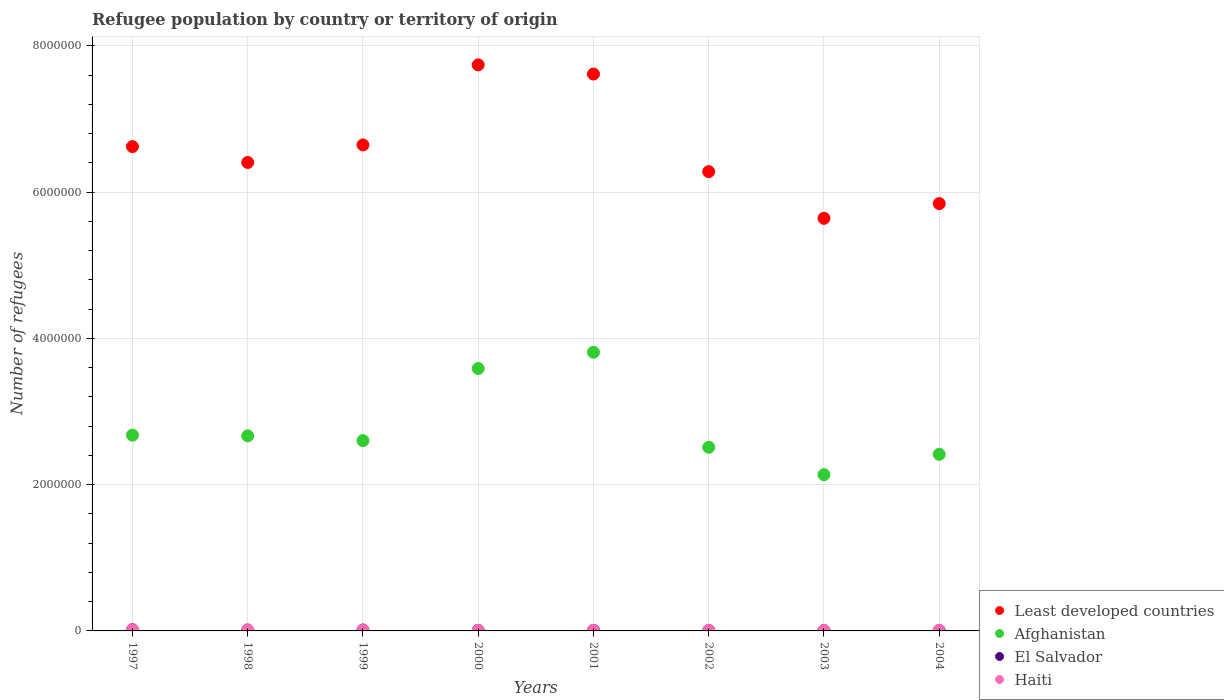Is the number of dotlines equal to the number of legend labels?
Provide a succinct answer. Yes. What is the number of refugees in El Salvador in 2004?
Your answer should be compact. 4497. Across all years, what is the maximum number of refugees in El Salvador?
Make the answer very short. 1.71e+04. Across all years, what is the minimum number of refugees in Haiti?
Make the answer very short. 7248. In which year was the number of refugees in Least developed countries maximum?
Ensure brevity in your answer.  2000. What is the total number of refugees in Haiti in the graph?
Provide a succinct answer. 7.71e+04. What is the difference between the number of refugees in Haiti in 1998 and that in 2001?
Make the answer very short. 6290. What is the difference between the number of refugees in El Salvador in 2003 and the number of refugees in Haiti in 2000?
Make the answer very short. -1903. What is the average number of refugees in El Salvador per year?
Provide a succinct answer. 9227.5. In the year 2003, what is the difference between the number of refugees in Afghanistan and number of refugees in El Salvador?
Give a very brief answer. 2.13e+06. In how many years, is the number of refugees in Haiti greater than 3200000?
Your answer should be very brief. 0. What is the ratio of the number of refugees in Afghanistan in 1997 to that in 2001?
Give a very brief answer. 0.7. Is the number of refugees in El Salvador in 1997 less than that in 1999?
Keep it short and to the point. No. Is the difference between the number of refugees in Afghanistan in 1997 and 2003 greater than the difference between the number of refugees in El Salvador in 1997 and 2003?
Make the answer very short. Yes. What is the difference between the highest and the second highest number of refugees in El Salvador?
Offer a terse response. 4535. What is the difference between the highest and the lowest number of refugees in Least developed countries?
Offer a terse response. 2.10e+06. Is the sum of the number of refugees in Afghanistan in 1999 and 2004 greater than the maximum number of refugees in Haiti across all years?
Keep it short and to the point. Yes. Is the number of refugees in El Salvador strictly greater than the number of refugees in Least developed countries over the years?
Make the answer very short. No. Are the values on the major ticks of Y-axis written in scientific E-notation?
Give a very brief answer. No. Does the graph contain grids?
Your response must be concise. Yes. Where does the legend appear in the graph?
Make the answer very short. Bottom right. How many legend labels are there?
Provide a succinct answer. 4. What is the title of the graph?
Make the answer very short. Refugee population by country or territory of origin. What is the label or title of the Y-axis?
Your answer should be very brief. Number of refugees. What is the Number of refugees in Least developed countries in 1997?
Your answer should be very brief. 6.62e+06. What is the Number of refugees of Afghanistan in 1997?
Make the answer very short. 2.68e+06. What is the Number of refugees of El Salvador in 1997?
Your answer should be very brief. 1.71e+04. What is the Number of refugees in Haiti in 1997?
Offer a terse response. 1.55e+04. What is the Number of refugees in Least developed countries in 1998?
Make the answer very short. 6.40e+06. What is the Number of refugees of Afghanistan in 1998?
Provide a succinct answer. 2.67e+06. What is the Number of refugees in El Salvador in 1998?
Keep it short and to the point. 1.26e+04. What is the Number of refugees in Haiti in 1998?
Make the answer very short. 1.35e+04. What is the Number of refugees of Least developed countries in 1999?
Your answer should be very brief. 6.64e+06. What is the Number of refugees in Afghanistan in 1999?
Keep it short and to the point. 2.60e+06. What is the Number of refugees in El Salvador in 1999?
Your answer should be compact. 1.24e+04. What is the Number of refugees of Haiti in 1999?
Give a very brief answer. 8766. What is the Number of refugees of Least developed countries in 2000?
Make the answer very short. 7.74e+06. What is the Number of refugees of Afghanistan in 2000?
Your response must be concise. 3.59e+06. What is the Number of refugees of El Salvador in 2000?
Offer a terse response. 7756. What is the Number of refugees of Haiti in 2000?
Your response must be concise. 7561. What is the Number of refugees of Least developed countries in 2001?
Ensure brevity in your answer.  7.61e+06. What is the Number of refugees of Afghanistan in 2001?
Your answer should be compact. 3.81e+06. What is the Number of refugees in El Salvador in 2001?
Offer a terse response. 7150. What is the Number of refugees in Haiti in 2001?
Offer a very short reply. 7248. What is the Number of refugees of Least developed countries in 2002?
Give a very brief answer. 6.28e+06. What is the Number of refugees of Afghanistan in 2002?
Provide a short and direct response. 2.51e+06. What is the Number of refugees of El Salvador in 2002?
Provide a short and direct response. 6632. What is the Number of refugees in Haiti in 2002?
Ensure brevity in your answer.  7718. What is the Number of refugees of Least developed countries in 2003?
Provide a short and direct response. 5.64e+06. What is the Number of refugees of Afghanistan in 2003?
Your response must be concise. 2.14e+06. What is the Number of refugees in El Salvador in 2003?
Give a very brief answer. 5658. What is the Number of refugees in Haiti in 2003?
Make the answer very short. 7547. What is the Number of refugees of Least developed countries in 2004?
Keep it short and to the point. 5.84e+06. What is the Number of refugees of Afghanistan in 2004?
Offer a very short reply. 2.41e+06. What is the Number of refugees in El Salvador in 2004?
Offer a very short reply. 4497. What is the Number of refugees in Haiti in 2004?
Make the answer very short. 9208. Across all years, what is the maximum Number of refugees of Least developed countries?
Offer a very short reply. 7.74e+06. Across all years, what is the maximum Number of refugees in Afghanistan?
Keep it short and to the point. 3.81e+06. Across all years, what is the maximum Number of refugees of El Salvador?
Give a very brief answer. 1.71e+04. Across all years, what is the maximum Number of refugees in Haiti?
Provide a short and direct response. 1.55e+04. Across all years, what is the minimum Number of refugees of Least developed countries?
Your answer should be compact. 5.64e+06. Across all years, what is the minimum Number of refugees in Afghanistan?
Give a very brief answer. 2.14e+06. Across all years, what is the minimum Number of refugees of El Salvador?
Ensure brevity in your answer.  4497. Across all years, what is the minimum Number of refugees of Haiti?
Ensure brevity in your answer.  7248. What is the total Number of refugees in Least developed countries in the graph?
Ensure brevity in your answer.  5.28e+07. What is the total Number of refugees in Afghanistan in the graph?
Offer a very short reply. 2.24e+07. What is the total Number of refugees of El Salvador in the graph?
Your answer should be compact. 7.38e+04. What is the total Number of refugees of Haiti in the graph?
Offer a very short reply. 7.71e+04. What is the difference between the Number of refugees in Least developed countries in 1997 and that in 1998?
Your answer should be very brief. 2.17e+05. What is the difference between the Number of refugees in Afghanistan in 1997 and that in 1998?
Keep it short and to the point. 9559. What is the difference between the Number of refugees in El Salvador in 1997 and that in 1998?
Offer a terse response. 4535. What is the difference between the Number of refugees of Haiti in 1997 and that in 1998?
Provide a short and direct response. 1943. What is the difference between the Number of refugees of Least developed countries in 1997 and that in 1999?
Ensure brevity in your answer.  -2.28e+04. What is the difference between the Number of refugees of Afghanistan in 1997 and that in 1999?
Your response must be concise. 7.50e+04. What is the difference between the Number of refugees of El Salvador in 1997 and that in 1999?
Keep it short and to the point. 4716. What is the difference between the Number of refugees of Haiti in 1997 and that in 1999?
Offer a very short reply. 6715. What is the difference between the Number of refugees in Least developed countries in 1997 and that in 2000?
Give a very brief answer. -1.12e+06. What is the difference between the Number of refugees of Afghanistan in 1997 and that in 2000?
Your answer should be very brief. -9.11e+05. What is the difference between the Number of refugees in El Salvador in 1997 and that in 2000?
Make the answer very short. 9370. What is the difference between the Number of refugees of Haiti in 1997 and that in 2000?
Make the answer very short. 7920. What is the difference between the Number of refugees of Least developed countries in 1997 and that in 2001?
Offer a very short reply. -9.92e+05. What is the difference between the Number of refugees in Afghanistan in 1997 and that in 2001?
Your answer should be compact. -1.13e+06. What is the difference between the Number of refugees of El Salvador in 1997 and that in 2001?
Keep it short and to the point. 9976. What is the difference between the Number of refugees in Haiti in 1997 and that in 2001?
Make the answer very short. 8233. What is the difference between the Number of refugees in Least developed countries in 1997 and that in 2002?
Offer a very short reply. 3.42e+05. What is the difference between the Number of refugees of Afghanistan in 1997 and that in 2002?
Offer a very short reply. 1.66e+05. What is the difference between the Number of refugees of El Salvador in 1997 and that in 2002?
Offer a terse response. 1.05e+04. What is the difference between the Number of refugees of Haiti in 1997 and that in 2002?
Give a very brief answer. 7763. What is the difference between the Number of refugees of Least developed countries in 1997 and that in 2003?
Your answer should be compact. 9.80e+05. What is the difference between the Number of refugees of Afghanistan in 1997 and that in 2003?
Your answer should be very brief. 5.41e+05. What is the difference between the Number of refugees in El Salvador in 1997 and that in 2003?
Offer a terse response. 1.15e+04. What is the difference between the Number of refugees in Haiti in 1997 and that in 2003?
Make the answer very short. 7934. What is the difference between the Number of refugees of Least developed countries in 1997 and that in 2004?
Give a very brief answer. 7.79e+05. What is the difference between the Number of refugees in Afghanistan in 1997 and that in 2004?
Your answer should be compact. 2.62e+05. What is the difference between the Number of refugees in El Salvador in 1997 and that in 2004?
Ensure brevity in your answer.  1.26e+04. What is the difference between the Number of refugees in Haiti in 1997 and that in 2004?
Offer a very short reply. 6273. What is the difference between the Number of refugees in Least developed countries in 1998 and that in 1999?
Provide a succinct answer. -2.40e+05. What is the difference between the Number of refugees in Afghanistan in 1998 and that in 1999?
Keep it short and to the point. 6.54e+04. What is the difference between the Number of refugees in El Salvador in 1998 and that in 1999?
Provide a short and direct response. 181. What is the difference between the Number of refugees of Haiti in 1998 and that in 1999?
Offer a very short reply. 4772. What is the difference between the Number of refugees of Least developed countries in 1998 and that in 2000?
Give a very brief answer. -1.33e+06. What is the difference between the Number of refugees in Afghanistan in 1998 and that in 2000?
Your answer should be very brief. -9.20e+05. What is the difference between the Number of refugees in El Salvador in 1998 and that in 2000?
Keep it short and to the point. 4835. What is the difference between the Number of refugees of Haiti in 1998 and that in 2000?
Offer a very short reply. 5977. What is the difference between the Number of refugees in Least developed countries in 1998 and that in 2001?
Provide a succinct answer. -1.21e+06. What is the difference between the Number of refugees in Afghanistan in 1998 and that in 2001?
Your answer should be compact. -1.14e+06. What is the difference between the Number of refugees of El Salvador in 1998 and that in 2001?
Give a very brief answer. 5441. What is the difference between the Number of refugees of Haiti in 1998 and that in 2001?
Provide a short and direct response. 6290. What is the difference between the Number of refugees of Least developed countries in 1998 and that in 2002?
Make the answer very short. 1.25e+05. What is the difference between the Number of refugees of Afghanistan in 1998 and that in 2002?
Give a very brief answer. 1.57e+05. What is the difference between the Number of refugees in El Salvador in 1998 and that in 2002?
Your response must be concise. 5959. What is the difference between the Number of refugees of Haiti in 1998 and that in 2002?
Offer a very short reply. 5820. What is the difference between the Number of refugees of Least developed countries in 1998 and that in 2003?
Keep it short and to the point. 7.63e+05. What is the difference between the Number of refugees in Afghanistan in 1998 and that in 2003?
Ensure brevity in your answer.  5.31e+05. What is the difference between the Number of refugees in El Salvador in 1998 and that in 2003?
Your response must be concise. 6933. What is the difference between the Number of refugees in Haiti in 1998 and that in 2003?
Your answer should be compact. 5991. What is the difference between the Number of refugees in Least developed countries in 1998 and that in 2004?
Offer a very short reply. 5.62e+05. What is the difference between the Number of refugees of Afghanistan in 1998 and that in 2004?
Your answer should be compact. 2.53e+05. What is the difference between the Number of refugees of El Salvador in 1998 and that in 2004?
Give a very brief answer. 8094. What is the difference between the Number of refugees in Haiti in 1998 and that in 2004?
Your answer should be compact. 4330. What is the difference between the Number of refugees in Least developed countries in 1999 and that in 2000?
Your answer should be very brief. -1.09e+06. What is the difference between the Number of refugees of Afghanistan in 1999 and that in 2000?
Keep it short and to the point. -9.86e+05. What is the difference between the Number of refugees in El Salvador in 1999 and that in 2000?
Keep it short and to the point. 4654. What is the difference between the Number of refugees of Haiti in 1999 and that in 2000?
Your answer should be very brief. 1205. What is the difference between the Number of refugees of Least developed countries in 1999 and that in 2001?
Ensure brevity in your answer.  -9.69e+05. What is the difference between the Number of refugees in Afghanistan in 1999 and that in 2001?
Offer a terse response. -1.21e+06. What is the difference between the Number of refugees in El Salvador in 1999 and that in 2001?
Offer a very short reply. 5260. What is the difference between the Number of refugees of Haiti in 1999 and that in 2001?
Give a very brief answer. 1518. What is the difference between the Number of refugees in Least developed countries in 1999 and that in 2002?
Provide a succinct answer. 3.64e+05. What is the difference between the Number of refugees of Afghanistan in 1999 and that in 2002?
Your answer should be compact. 9.14e+04. What is the difference between the Number of refugees of El Salvador in 1999 and that in 2002?
Your answer should be compact. 5778. What is the difference between the Number of refugees of Haiti in 1999 and that in 2002?
Provide a succinct answer. 1048. What is the difference between the Number of refugees of Least developed countries in 1999 and that in 2003?
Your answer should be compact. 1.00e+06. What is the difference between the Number of refugees of Afghanistan in 1999 and that in 2003?
Offer a very short reply. 4.66e+05. What is the difference between the Number of refugees in El Salvador in 1999 and that in 2003?
Offer a terse response. 6752. What is the difference between the Number of refugees in Haiti in 1999 and that in 2003?
Offer a very short reply. 1219. What is the difference between the Number of refugees in Least developed countries in 1999 and that in 2004?
Your answer should be compact. 8.02e+05. What is the difference between the Number of refugees in Afghanistan in 1999 and that in 2004?
Your response must be concise. 1.87e+05. What is the difference between the Number of refugees of El Salvador in 1999 and that in 2004?
Provide a short and direct response. 7913. What is the difference between the Number of refugees in Haiti in 1999 and that in 2004?
Your response must be concise. -442. What is the difference between the Number of refugees of Least developed countries in 2000 and that in 2001?
Provide a short and direct response. 1.26e+05. What is the difference between the Number of refugees in Afghanistan in 2000 and that in 2001?
Give a very brief answer. -2.22e+05. What is the difference between the Number of refugees of El Salvador in 2000 and that in 2001?
Make the answer very short. 606. What is the difference between the Number of refugees in Haiti in 2000 and that in 2001?
Provide a short and direct response. 313. What is the difference between the Number of refugees of Least developed countries in 2000 and that in 2002?
Give a very brief answer. 1.46e+06. What is the difference between the Number of refugees of Afghanistan in 2000 and that in 2002?
Your answer should be compact. 1.08e+06. What is the difference between the Number of refugees in El Salvador in 2000 and that in 2002?
Offer a very short reply. 1124. What is the difference between the Number of refugees of Haiti in 2000 and that in 2002?
Give a very brief answer. -157. What is the difference between the Number of refugees of Least developed countries in 2000 and that in 2003?
Keep it short and to the point. 2.10e+06. What is the difference between the Number of refugees in Afghanistan in 2000 and that in 2003?
Your response must be concise. 1.45e+06. What is the difference between the Number of refugees in El Salvador in 2000 and that in 2003?
Keep it short and to the point. 2098. What is the difference between the Number of refugees of Least developed countries in 2000 and that in 2004?
Make the answer very short. 1.90e+06. What is the difference between the Number of refugees in Afghanistan in 2000 and that in 2004?
Ensure brevity in your answer.  1.17e+06. What is the difference between the Number of refugees in El Salvador in 2000 and that in 2004?
Ensure brevity in your answer.  3259. What is the difference between the Number of refugees of Haiti in 2000 and that in 2004?
Provide a short and direct response. -1647. What is the difference between the Number of refugees in Least developed countries in 2001 and that in 2002?
Give a very brief answer. 1.33e+06. What is the difference between the Number of refugees of Afghanistan in 2001 and that in 2002?
Your answer should be very brief. 1.30e+06. What is the difference between the Number of refugees of El Salvador in 2001 and that in 2002?
Make the answer very short. 518. What is the difference between the Number of refugees of Haiti in 2001 and that in 2002?
Your response must be concise. -470. What is the difference between the Number of refugees of Least developed countries in 2001 and that in 2003?
Give a very brief answer. 1.97e+06. What is the difference between the Number of refugees in Afghanistan in 2001 and that in 2003?
Provide a short and direct response. 1.67e+06. What is the difference between the Number of refugees in El Salvador in 2001 and that in 2003?
Ensure brevity in your answer.  1492. What is the difference between the Number of refugees of Haiti in 2001 and that in 2003?
Keep it short and to the point. -299. What is the difference between the Number of refugees in Least developed countries in 2001 and that in 2004?
Provide a short and direct response. 1.77e+06. What is the difference between the Number of refugees of Afghanistan in 2001 and that in 2004?
Ensure brevity in your answer.  1.40e+06. What is the difference between the Number of refugees in El Salvador in 2001 and that in 2004?
Provide a succinct answer. 2653. What is the difference between the Number of refugees in Haiti in 2001 and that in 2004?
Provide a short and direct response. -1960. What is the difference between the Number of refugees in Least developed countries in 2002 and that in 2003?
Ensure brevity in your answer.  6.39e+05. What is the difference between the Number of refugees of Afghanistan in 2002 and that in 2003?
Offer a terse response. 3.74e+05. What is the difference between the Number of refugees in El Salvador in 2002 and that in 2003?
Your answer should be compact. 974. What is the difference between the Number of refugees in Haiti in 2002 and that in 2003?
Offer a terse response. 171. What is the difference between the Number of refugees of Least developed countries in 2002 and that in 2004?
Provide a short and direct response. 4.38e+05. What is the difference between the Number of refugees in Afghanistan in 2002 and that in 2004?
Make the answer very short. 9.59e+04. What is the difference between the Number of refugees in El Salvador in 2002 and that in 2004?
Your response must be concise. 2135. What is the difference between the Number of refugees in Haiti in 2002 and that in 2004?
Provide a succinct answer. -1490. What is the difference between the Number of refugees of Least developed countries in 2003 and that in 2004?
Ensure brevity in your answer.  -2.01e+05. What is the difference between the Number of refugees of Afghanistan in 2003 and that in 2004?
Your answer should be very brief. -2.78e+05. What is the difference between the Number of refugees of El Salvador in 2003 and that in 2004?
Your answer should be compact. 1161. What is the difference between the Number of refugees of Haiti in 2003 and that in 2004?
Your answer should be very brief. -1661. What is the difference between the Number of refugees of Least developed countries in 1997 and the Number of refugees of Afghanistan in 1998?
Your answer should be very brief. 3.95e+06. What is the difference between the Number of refugees of Least developed countries in 1997 and the Number of refugees of El Salvador in 1998?
Provide a succinct answer. 6.61e+06. What is the difference between the Number of refugees in Least developed countries in 1997 and the Number of refugees in Haiti in 1998?
Keep it short and to the point. 6.61e+06. What is the difference between the Number of refugees in Afghanistan in 1997 and the Number of refugees in El Salvador in 1998?
Your response must be concise. 2.66e+06. What is the difference between the Number of refugees in Afghanistan in 1997 and the Number of refugees in Haiti in 1998?
Ensure brevity in your answer.  2.66e+06. What is the difference between the Number of refugees of El Salvador in 1997 and the Number of refugees of Haiti in 1998?
Offer a terse response. 3588. What is the difference between the Number of refugees of Least developed countries in 1997 and the Number of refugees of Afghanistan in 1999?
Offer a very short reply. 4.02e+06. What is the difference between the Number of refugees in Least developed countries in 1997 and the Number of refugees in El Salvador in 1999?
Offer a very short reply. 6.61e+06. What is the difference between the Number of refugees in Least developed countries in 1997 and the Number of refugees in Haiti in 1999?
Ensure brevity in your answer.  6.61e+06. What is the difference between the Number of refugees in Afghanistan in 1997 and the Number of refugees in El Salvador in 1999?
Your answer should be compact. 2.66e+06. What is the difference between the Number of refugees of Afghanistan in 1997 and the Number of refugees of Haiti in 1999?
Offer a very short reply. 2.67e+06. What is the difference between the Number of refugees of El Salvador in 1997 and the Number of refugees of Haiti in 1999?
Your response must be concise. 8360. What is the difference between the Number of refugees of Least developed countries in 1997 and the Number of refugees of Afghanistan in 2000?
Your answer should be very brief. 3.03e+06. What is the difference between the Number of refugees in Least developed countries in 1997 and the Number of refugees in El Salvador in 2000?
Provide a succinct answer. 6.61e+06. What is the difference between the Number of refugees of Least developed countries in 1997 and the Number of refugees of Haiti in 2000?
Offer a terse response. 6.61e+06. What is the difference between the Number of refugees in Afghanistan in 1997 and the Number of refugees in El Salvador in 2000?
Give a very brief answer. 2.67e+06. What is the difference between the Number of refugees in Afghanistan in 1997 and the Number of refugees in Haiti in 2000?
Make the answer very short. 2.67e+06. What is the difference between the Number of refugees of El Salvador in 1997 and the Number of refugees of Haiti in 2000?
Give a very brief answer. 9565. What is the difference between the Number of refugees of Least developed countries in 1997 and the Number of refugees of Afghanistan in 2001?
Offer a terse response. 2.81e+06. What is the difference between the Number of refugees of Least developed countries in 1997 and the Number of refugees of El Salvador in 2001?
Your response must be concise. 6.61e+06. What is the difference between the Number of refugees of Least developed countries in 1997 and the Number of refugees of Haiti in 2001?
Provide a succinct answer. 6.61e+06. What is the difference between the Number of refugees of Afghanistan in 1997 and the Number of refugees of El Salvador in 2001?
Your answer should be compact. 2.67e+06. What is the difference between the Number of refugees in Afghanistan in 1997 and the Number of refugees in Haiti in 2001?
Make the answer very short. 2.67e+06. What is the difference between the Number of refugees of El Salvador in 1997 and the Number of refugees of Haiti in 2001?
Your answer should be compact. 9878. What is the difference between the Number of refugees in Least developed countries in 1997 and the Number of refugees in Afghanistan in 2002?
Make the answer very short. 4.11e+06. What is the difference between the Number of refugees in Least developed countries in 1997 and the Number of refugees in El Salvador in 2002?
Ensure brevity in your answer.  6.61e+06. What is the difference between the Number of refugees in Least developed countries in 1997 and the Number of refugees in Haiti in 2002?
Keep it short and to the point. 6.61e+06. What is the difference between the Number of refugees in Afghanistan in 1997 and the Number of refugees in El Salvador in 2002?
Offer a very short reply. 2.67e+06. What is the difference between the Number of refugees of Afghanistan in 1997 and the Number of refugees of Haiti in 2002?
Offer a very short reply. 2.67e+06. What is the difference between the Number of refugees in El Salvador in 1997 and the Number of refugees in Haiti in 2002?
Give a very brief answer. 9408. What is the difference between the Number of refugees in Least developed countries in 1997 and the Number of refugees in Afghanistan in 2003?
Offer a terse response. 4.49e+06. What is the difference between the Number of refugees of Least developed countries in 1997 and the Number of refugees of El Salvador in 2003?
Provide a short and direct response. 6.62e+06. What is the difference between the Number of refugees in Least developed countries in 1997 and the Number of refugees in Haiti in 2003?
Give a very brief answer. 6.61e+06. What is the difference between the Number of refugees of Afghanistan in 1997 and the Number of refugees of El Salvador in 2003?
Your answer should be compact. 2.67e+06. What is the difference between the Number of refugees in Afghanistan in 1997 and the Number of refugees in Haiti in 2003?
Provide a succinct answer. 2.67e+06. What is the difference between the Number of refugees in El Salvador in 1997 and the Number of refugees in Haiti in 2003?
Ensure brevity in your answer.  9579. What is the difference between the Number of refugees of Least developed countries in 1997 and the Number of refugees of Afghanistan in 2004?
Your answer should be compact. 4.21e+06. What is the difference between the Number of refugees of Least developed countries in 1997 and the Number of refugees of El Salvador in 2004?
Give a very brief answer. 6.62e+06. What is the difference between the Number of refugees in Least developed countries in 1997 and the Number of refugees in Haiti in 2004?
Provide a short and direct response. 6.61e+06. What is the difference between the Number of refugees of Afghanistan in 1997 and the Number of refugees of El Salvador in 2004?
Keep it short and to the point. 2.67e+06. What is the difference between the Number of refugees of Afghanistan in 1997 and the Number of refugees of Haiti in 2004?
Offer a very short reply. 2.67e+06. What is the difference between the Number of refugees of El Salvador in 1997 and the Number of refugees of Haiti in 2004?
Provide a succinct answer. 7918. What is the difference between the Number of refugees of Least developed countries in 1998 and the Number of refugees of Afghanistan in 1999?
Your answer should be very brief. 3.80e+06. What is the difference between the Number of refugees of Least developed countries in 1998 and the Number of refugees of El Salvador in 1999?
Provide a short and direct response. 6.39e+06. What is the difference between the Number of refugees of Least developed countries in 1998 and the Number of refugees of Haiti in 1999?
Your answer should be compact. 6.40e+06. What is the difference between the Number of refugees of Afghanistan in 1998 and the Number of refugees of El Salvador in 1999?
Provide a short and direct response. 2.65e+06. What is the difference between the Number of refugees in Afghanistan in 1998 and the Number of refugees in Haiti in 1999?
Offer a terse response. 2.66e+06. What is the difference between the Number of refugees in El Salvador in 1998 and the Number of refugees in Haiti in 1999?
Provide a succinct answer. 3825. What is the difference between the Number of refugees in Least developed countries in 1998 and the Number of refugees in Afghanistan in 2000?
Make the answer very short. 2.82e+06. What is the difference between the Number of refugees of Least developed countries in 1998 and the Number of refugees of El Salvador in 2000?
Your answer should be very brief. 6.40e+06. What is the difference between the Number of refugees of Least developed countries in 1998 and the Number of refugees of Haiti in 2000?
Your answer should be very brief. 6.40e+06. What is the difference between the Number of refugees of Afghanistan in 1998 and the Number of refugees of El Salvador in 2000?
Make the answer very short. 2.66e+06. What is the difference between the Number of refugees in Afghanistan in 1998 and the Number of refugees in Haiti in 2000?
Make the answer very short. 2.66e+06. What is the difference between the Number of refugees in El Salvador in 1998 and the Number of refugees in Haiti in 2000?
Provide a short and direct response. 5030. What is the difference between the Number of refugees in Least developed countries in 1998 and the Number of refugees in Afghanistan in 2001?
Offer a very short reply. 2.59e+06. What is the difference between the Number of refugees in Least developed countries in 1998 and the Number of refugees in El Salvador in 2001?
Make the answer very short. 6.40e+06. What is the difference between the Number of refugees of Least developed countries in 1998 and the Number of refugees of Haiti in 2001?
Keep it short and to the point. 6.40e+06. What is the difference between the Number of refugees in Afghanistan in 1998 and the Number of refugees in El Salvador in 2001?
Your answer should be compact. 2.66e+06. What is the difference between the Number of refugees in Afghanistan in 1998 and the Number of refugees in Haiti in 2001?
Your response must be concise. 2.66e+06. What is the difference between the Number of refugees of El Salvador in 1998 and the Number of refugees of Haiti in 2001?
Your answer should be very brief. 5343. What is the difference between the Number of refugees of Least developed countries in 1998 and the Number of refugees of Afghanistan in 2002?
Provide a short and direct response. 3.89e+06. What is the difference between the Number of refugees in Least developed countries in 1998 and the Number of refugees in El Salvador in 2002?
Your response must be concise. 6.40e+06. What is the difference between the Number of refugees of Least developed countries in 1998 and the Number of refugees of Haiti in 2002?
Provide a succinct answer. 6.40e+06. What is the difference between the Number of refugees of Afghanistan in 1998 and the Number of refugees of El Salvador in 2002?
Ensure brevity in your answer.  2.66e+06. What is the difference between the Number of refugees in Afghanistan in 1998 and the Number of refugees in Haiti in 2002?
Ensure brevity in your answer.  2.66e+06. What is the difference between the Number of refugees in El Salvador in 1998 and the Number of refugees in Haiti in 2002?
Offer a terse response. 4873. What is the difference between the Number of refugees of Least developed countries in 1998 and the Number of refugees of Afghanistan in 2003?
Offer a very short reply. 4.27e+06. What is the difference between the Number of refugees of Least developed countries in 1998 and the Number of refugees of El Salvador in 2003?
Your answer should be compact. 6.40e+06. What is the difference between the Number of refugees in Least developed countries in 1998 and the Number of refugees in Haiti in 2003?
Provide a short and direct response. 6.40e+06. What is the difference between the Number of refugees of Afghanistan in 1998 and the Number of refugees of El Salvador in 2003?
Your answer should be compact. 2.66e+06. What is the difference between the Number of refugees in Afghanistan in 1998 and the Number of refugees in Haiti in 2003?
Ensure brevity in your answer.  2.66e+06. What is the difference between the Number of refugees in El Salvador in 1998 and the Number of refugees in Haiti in 2003?
Your answer should be compact. 5044. What is the difference between the Number of refugees in Least developed countries in 1998 and the Number of refugees in Afghanistan in 2004?
Ensure brevity in your answer.  3.99e+06. What is the difference between the Number of refugees in Least developed countries in 1998 and the Number of refugees in El Salvador in 2004?
Give a very brief answer. 6.40e+06. What is the difference between the Number of refugees in Least developed countries in 1998 and the Number of refugees in Haiti in 2004?
Ensure brevity in your answer.  6.40e+06. What is the difference between the Number of refugees in Afghanistan in 1998 and the Number of refugees in El Salvador in 2004?
Make the answer very short. 2.66e+06. What is the difference between the Number of refugees of Afghanistan in 1998 and the Number of refugees of Haiti in 2004?
Your response must be concise. 2.66e+06. What is the difference between the Number of refugees in El Salvador in 1998 and the Number of refugees in Haiti in 2004?
Your answer should be very brief. 3383. What is the difference between the Number of refugees of Least developed countries in 1999 and the Number of refugees of Afghanistan in 2000?
Your response must be concise. 3.06e+06. What is the difference between the Number of refugees in Least developed countries in 1999 and the Number of refugees in El Salvador in 2000?
Make the answer very short. 6.64e+06. What is the difference between the Number of refugees of Least developed countries in 1999 and the Number of refugees of Haiti in 2000?
Offer a very short reply. 6.64e+06. What is the difference between the Number of refugees of Afghanistan in 1999 and the Number of refugees of El Salvador in 2000?
Give a very brief answer. 2.59e+06. What is the difference between the Number of refugees in Afghanistan in 1999 and the Number of refugees in Haiti in 2000?
Make the answer very short. 2.59e+06. What is the difference between the Number of refugees in El Salvador in 1999 and the Number of refugees in Haiti in 2000?
Your answer should be compact. 4849. What is the difference between the Number of refugees of Least developed countries in 1999 and the Number of refugees of Afghanistan in 2001?
Provide a succinct answer. 2.83e+06. What is the difference between the Number of refugees in Least developed countries in 1999 and the Number of refugees in El Salvador in 2001?
Your response must be concise. 6.64e+06. What is the difference between the Number of refugees in Least developed countries in 1999 and the Number of refugees in Haiti in 2001?
Make the answer very short. 6.64e+06. What is the difference between the Number of refugees in Afghanistan in 1999 and the Number of refugees in El Salvador in 2001?
Offer a very short reply. 2.59e+06. What is the difference between the Number of refugees in Afghanistan in 1999 and the Number of refugees in Haiti in 2001?
Provide a short and direct response. 2.59e+06. What is the difference between the Number of refugees in El Salvador in 1999 and the Number of refugees in Haiti in 2001?
Provide a short and direct response. 5162. What is the difference between the Number of refugees in Least developed countries in 1999 and the Number of refugees in Afghanistan in 2002?
Provide a short and direct response. 4.13e+06. What is the difference between the Number of refugees in Least developed countries in 1999 and the Number of refugees in El Salvador in 2002?
Offer a very short reply. 6.64e+06. What is the difference between the Number of refugees in Least developed countries in 1999 and the Number of refugees in Haiti in 2002?
Ensure brevity in your answer.  6.64e+06. What is the difference between the Number of refugees in Afghanistan in 1999 and the Number of refugees in El Salvador in 2002?
Keep it short and to the point. 2.60e+06. What is the difference between the Number of refugees of Afghanistan in 1999 and the Number of refugees of Haiti in 2002?
Ensure brevity in your answer.  2.59e+06. What is the difference between the Number of refugees in El Salvador in 1999 and the Number of refugees in Haiti in 2002?
Ensure brevity in your answer.  4692. What is the difference between the Number of refugees in Least developed countries in 1999 and the Number of refugees in Afghanistan in 2003?
Ensure brevity in your answer.  4.51e+06. What is the difference between the Number of refugees of Least developed countries in 1999 and the Number of refugees of El Salvador in 2003?
Offer a terse response. 6.64e+06. What is the difference between the Number of refugees in Least developed countries in 1999 and the Number of refugees in Haiti in 2003?
Keep it short and to the point. 6.64e+06. What is the difference between the Number of refugees of Afghanistan in 1999 and the Number of refugees of El Salvador in 2003?
Provide a succinct answer. 2.60e+06. What is the difference between the Number of refugees of Afghanistan in 1999 and the Number of refugees of Haiti in 2003?
Your answer should be compact. 2.59e+06. What is the difference between the Number of refugees of El Salvador in 1999 and the Number of refugees of Haiti in 2003?
Ensure brevity in your answer.  4863. What is the difference between the Number of refugees in Least developed countries in 1999 and the Number of refugees in Afghanistan in 2004?
Your answer should be very brief. 4.23e+06. What is the difference between the Number of refugees in Least developed countries in 1999 and the Number of refugees in El Salvador in 2004?
Offer a terse response. 6.64e+06. What is the difference between the Number of refugees in Least developed countries in 1999 and the Number of refugees in Haiti in 2004?
Ensure brevity in your answer.  6.64e+06. What is the difference between the Number of refugees in Afghanistan in 1999 and the Number of refugees in El Salvador in 2004?
Offer a very short reply. 2.60e+06. What is the difference between the Number of refugees in Afghanistan in 1999 and the Number of refugees in Haiti in 2004?
Keep it short and to the point. 2.59e+06. What is the difference between the Number of refugees of El Salvador in 1999 and the Number of refugees of Haiti in 2004?
Offer a very short reply. 3202. What is the difference between the Number of refugees of Least developed countries in 2000 and the Number of refugees of Afghanistan in 2001?
Ensure brevity in your answer.  3.93e+06. What is the difference between the Number of refugees in Least developed countries in 2000 and the Number of refugees in El Salvador in 2001?
Make the answer very short. 7.73e+06. What is the difference between the Number of refugees of Least developed countries in 2000 and the Number of refugees of Haiti in 2001?
Your response must be concise. 7.73e+06. What is the difference between the Number of refugees in Afghanistan in 2000 and the Number of refugees in El Salvador in 2001?
Your response must be concise. 3.58e+06. What is the difference between the Number of refugees of Afghanistan in 2000 and the Number of refugees of Haiti in 2001?
Offer a very short reply. 3.58e+06. What is the difference between the Number of refugees in El Salvador in 2000 and the Number of refugees in Haiti in 2001?
Make the answer very short. 508. What is the difference between the Number of refugees in Least developed countries in 2000 and the Number of refugees in Afghanistan in 2002?
Offer a terse response. 5.23e+06. What is the difference between the Number of refugees of Least developed countries in 2000 and the Number of refugees of El Salvador in 2002?
Your answer should be very brief. 7.73e+06. What is the difference between the Number of refugees in Least developed countries in 2000 and the Number of refugees in Haiti in 2002?
Give a very brief answer. 7.73e+06. What is the difference between the Number of refugees in Afghanistan in 2000 and the Number of refugees in El Salvador in 2002?
Make the answer very short. 3.58e+06. What is the difference between the Number of refugees of Afghanistan in 2000 and the Number of refugees of Haiti in 2002?
Offer a terse response. 3.58e+06. What is the difference between the Number of refugees in El Salvador in 2000 and the Number of refugees in Haiti in 2002?
Offer a very short reply. 38. What is the difference between the Number of refugees in Least developed countries in 2000 and the Number of refugees in Afghanistan in 2003?
Ensure brevity in your answer.  5.60e+06. What is the difference between the Number of refugees in Least developed countries in 2000 and the Number of refugees in El Salvador in 2003?
Ensure brevity in your answer.  7.73e+06. What is the difference between the Number of refugees of Least developed countries in 2000 and the Number of refugees of Haiti in 2003?
Give a very brief answer. 7.73e+06. What is the difference between the Number of refugees in Afghanistan in 2000 and the Number of refugees in El Salvador in 2003?
Your answer should be compact. 3.58e+06. What is the difference between the Number of refugees of Afghanistan in 2000 and the Number of refugees of Haiti in 2003?
Give a very brief answer. 3.58e+06. What is the difference between the Number of refugees in El Salvador in 2000 and the Number of refugees in Haiti in 2003?
Your answer should be very brief. 209. What is the difference between the Number of refugees in Least developed countries in 2000 and the Number of refugees in Afghanistan in 2004?
Give a very brief answer. 5.32e+06. What is the difference between the Number of refugees in Least developed countries in 2000 and the Number of refugees in El Salvador in 2004?
Your answer should be very brief. 7.73e+06. What is the difference between the Number of refugees in Least developed countries in 2000 and the Number of refugees in Haiti in 2004?
Give a very brief answer. 7.73e+06. What is the difference between the Number of refugees of Afghanistan in 2000 and the Number of refugees of El Salvador in 2004?
Ensure brevity in your answer.  3.58e+06. What is the difference between the Number of refugees of Afghanistan in 2000 and the Number of refugees of Haiti in 2004?
Provide a short and direct response. 3.58e+06. What is the difference between the Number of refugees in El Salvador in 2000 and the Number of refugees in Haiti in 2004?
Give a very brief answer. -1452. What is the difference between the Number of refugees of Least developed countries in 2001 and the Number of refugees of Afghanistan in 2002?
Your answer should be very brief. 5.10e+06. What is the difference between the Number of refugees in Least developed countries in 2001 and the Number of refugees in El Salvador in 2002?
Provide a short and direct response. 7.61e+06. What is the difference between the Number of refugees in Least developed countries in 2001 and the Number of refugees in Haiti in 2002?
Keep it short and to the point. 7.61e+06. What is the difference between the Number of refugees of Afghanistan in 2001 and the Number of refugees of El Salvador in 2002?
Provide a succinct answer. 3.80e+06. What is the difference between the Number of refugees of Afghanistan in 2001 and the Number of refugees of Haiti in 2002?
Offer a terse response. 3.80e+06. What is the difference between the Number of refugees in El Salvador in 2001 and the Number of refugees in Haiti in 2002?
Your answer should be very brief. -568. What is the difference between the Number of refugees of Least developed countries in 2001 and the Number of refugees of Afghanistan in 2003?
Keep it short and to the point. 5.48e+06. What is the difference between the Number of refugees in Least developed countries in 2001 and the Number of refugees in El Salvador in 2003?
Provide a short and direct response. 7.61e+06. What is the difference between the Number of refugees in Least developed countries in 2001 and the Number of refugees in Haiti in 2003?
Offer a terse response. 7.61e+06. What is the difference between the Number of refugees in Afghanistan in 2001 and the Number of refugees in El Salvador in 2003?
Keep it short and to the point. 3.80e+06. What is the difference between the Number of refugees of Afghanistan in 2001 and the Number of refugees of Haiti in 2003?
Your answer should be compact. 3.80e+06. What is the difference between the Number of refugees of El Salvador in 2001 and the Number of refugees of Haiti in 2003?
Your response must be concise. -397. What is the difference between the Number of refugees in Least developed countries in 2001 and the Number of refugees in Afghanistan in 2004?
Your response must be concise. 5.20e+06. What is the difference between the Number of refugees in Least developed countries in 2001 and the Number of refugees in El Salvador in 2004?
Your answer should be very brief. 7.61e+06. What is the difference between the Number of refugees in Least developed countries in 2001 and the Number of refugees in Haiti in 2004?
Provide a succinct answer. 7.60e+06. What is the difference between the Number of refugees in Afghanistan in 2001 and the Number of refugees in El Salvador in 2004?
Your answer should be compact. 3.81e+06. What is the difference between the Number of refugees in Afghanistan in 2001 and the Number of refugees in Haiti in 2004?
Offer a very short reply. 3.80e+06. What is the difference between the Number of refugees of El Salvador in 2001 and the Number of refugees of Haiti in 2004?
Your answer should be very brief. -2058. What is the difference between the Number of refugees in Least developed countries in 2002 and the Number of refugees in Afghanistan in 2003?
Make the answer very short. 4.14e+06. What is the difference between the Number of refugees in Least developed countries in 2002 and the Number of refugees in El Salvador in 2003?
Your answer should be compact. 6.27e+06. What is the difference between the Number of refugees of Least developed countries in 2002 and the Number of refugees of Haiti in 2003?
Make the answer very short. 6.27e+06. What is the difference between the Number of refugees in Afghanistan in 2002 and the Number of refugees in El Salvador in 2003?
Ensure brevity in your answer.  2.50e+06. What is the difference between the Number of refugees of Afghanistan in 2002 and the Number of refugees of Haiti in 2003?
Your response must be concise. 2.50e+06. What is the difference between the Number of refugees in El Salvador in 2002 and the Number of refugees in Haiti in 2003?
Ensure brevity in your answer.  -915. What is the difference between the Number of refugees in Least developed countries in 2002 and the Number of refugees in Afghanistan in 2004?
Keep it short and to the point. 3.87e+06. What is the difference between the Number of refugees in Least developed countries in 2002 and the Number of refugees in El Salvador in 2004?
Make the answer very short. 6.28e+06. What is the difference between the Number of refugees in Least developed countries in 2002 and the Number of refugees in Haiti in 2004?
Your answer should be compact. 6.27e+06. What is the difference between the Number of refugees of Afghanistan in 2002 and the Number of refugees of El Salvador in 2004?
Offer a terse response. 2.51e+06. What is the difference between the Number of refugees in Afghanistan in 2002 and the Number of refugees in Haiti in 2004?
Provide a succinct answer. 2.50e+06. What is the difference between the Number of refugees in El Salvador in 2002 and the Number of refugees in Haiti in 2004?
Your answer should be compact. -2576. What is the difference between the Number of refugees of Least developed countries in 2003 and the Number of refugees of Afghanistan in 2004?
Offer a terse response. 3.23e+06. What is the difference between the Number of refugees of Least developed countries in 2003 and the Number of refugees of El Salvador in 2004?
Make the answer very short. 5.64e+06. What is the difference between the Number of refugees in Least developed countries in 2003 and the Number of refugees in Haiti in 2004?
Offer a terse response. 5.63e+06. What is the difference between the Number of refugees in Afghanistan in 2003 and the Number of refugees in El Salvador in 2004?
Your answer should be very brief. 2.13e+06. What is the difference between the Number of refugees in Afghanistan in 2003 and the Number of refugees in Haiti in 2004?
Offer a terse response. 2.13e+06. What is the difference between the Number of refugees of El Salvador in 2003 and the Number of refugees of Haiti in 2004?
Offer a very short reply. -3550. What is the average Number of refugees of Least developed countries per year?
Offer a terse response. 6.60e+06. What is the average Number of refugees in Afghanistan per year?
Ensure brevity in your answer.  2.80e+06. What is the average Number of refugees of El Salvador per year?
Ensure brevity in your answer.  9227.5. What is the average Number of refugees in Haiti per year?
Provide a short and direct response. 9633.38. In the year 1997, what is the difference between the Number of refugees of Least developed countries and Number of refugees of Afghanistan?
Make the answer very short. 3.94e+06. In the year 1997, what is the difference between the Number of refugees in Least developed countries and Number of refugees in El Salvador?
Provide a succinct answer. 6.60e+06. In the year 1997, what is the difference between the Number of refugees in Least developed countries and Number of refugees in Haiti?
Provide a succinct answer. 6.61e+06. In the year 1997, what is the difference between the Number of refugees of Afghanistan and Number of refugees of El Salvador?
Make the answer very short. 2.66e+06. In the year 1997, what is the difference between the Number of refugees in Afghanistan and Number of refugees in Haiti?
Keep it short and to the point. 2.66e+06. In the year 1997, what is the difference between the Number of refugees in El Salvador and Number of refugees in Haiti?
Your answer should be compact. 1645. In the year 1998, what is the difference between the Number of refugees of Least developed countries and Number of refugees of Afghanistan?
Offer a very short reply. 3.74e+06. In the year 1998, what is the difference between the Number of refugees of Least developed countries and Number of refugees of El Salvador?
Give a very brief answer. 6.39e+06. In the year 1998, what is the difference between the Number of refugees of Least developed countries and Number of refugees of Haiti?
Give a very brief answer. 6.39e+06. In the year 1998, what is the difference between the Number of refugees in Afghanistan and Number of refugees in El Salvador?
Make the answer very short. 2.65e+06. In the year 1998, what is the difference between the Number of refugees of Afghanistan and Number of refugees of Haiti?
Give a very brief answer. 2.65e+06. In the year 1998, what is the difference between the Number of refugees in El Salvador and Number of refugees in Haiti?
Offer a very short reply. -947. In the year 1999, what is the difference between the Number of refugees of Least developed countries and Number of refugees of Afghanistan?
Offer a very short reply. 4.04e+06. In the year 1999, what is the difference between the Number of refugees in Least developed countries and Number of refugees in El Salvador?
Offer a very short reply. 6.63e+06. In the year 1999, what is the difference between the Number of refugees in Least developed countries and Number of refugees in Haiti?
Provide a short and direct response. 6.64e+06. In the year 1999, what is the difference between the Number of refugees of Afghanistan and Number of refugees of El Salvador?
Ensure brevity in your answer.  2.59e+06. In the year 1999, what is the difference between the Number of refugees in Afghanistan and Number of refugees in Haiti?
Keep it short and to the point. 2.59e+06. In the year 1999, what is the difference between the Number of refugees in El Salvador and Number of refugees in Haiti?
Make the answer very short. 3644. In the year 2000, what is the difference between the Number of refugees in Least developed countries and Number of refugees in Afghanistan?
Ensure brevity in your answer.  4.15e+06. In the year 2000, what is the difference between the Number of refugees in Least developed countries and Number of refugees in El Salvador?
Your answer should be compact. 7.73e+06. In the year 2000, what is the difference between the Number of refugees of Least developed countries and Number of refugees of Haiti?
Make the answer very short. 7.73e+06. In the year 2000, what is the difference between the Number of refugees of Afghanistan and Number of refugees of El Salvador?
Your response must be concise. 3.58e+06. In the year 2000, what is the difference between the Number of refugees in Afghanistan and Number of refugees in Haiti?
Your answer should be very brief. 3.58e+06. In the year 2000, what is the difference between the Number of refugees of El Salvador and Number of refugees of Haiti?
Offer a very short reply. 195. In the year 2001, what is the difference between the Number of refugees of Least developed countries and Number of refugees of Afghanistan?
Keep it short and to the point. 3.80e+06. In the year 2001, what is the difference between the Number of refugees of Least developed countries and Number of refugees of El Salvador?
Ensure brevity in your answer.  7.61e+06. In the year 2001, what is the difference between the Number of refugees of Least developed countries and Number of refugees of Haiti?
Ensure brevity in your answer.  7.61e+06. In the year 2001, what is the difference between the Number of refugees in Afghanistan and Number of refugees in El Salvador?
Your answer should be compact. 3.80e+06. In the year 2001, what is the difference between the Number of refugees in Afghanistan and Number of refugees in Haiti?
Keep it short and to the point. 3.80e+06. In the year 2001, what is the difference between the Number of refugees of El Salvador and Number of refugees of Haiti?
Offer a terse response. -98. In the year 2002, what is the difference between the Number of refugees in Least developed countries and Number of refugees in Afghanistan?
Make the answer very short. 3.77e+06. In the year 2002, what is the difference between the Number of refugees of Least developed countries and Number of refugees of El Salvador?
Offer a terse response. 6.27e+06. In the year 2002, what is the difference between the Number of refugees in Least developed countries and Number of refugees in Haiti?
Offer a very short reply. 6.27e+06. In the year 2002, what is the difference between the Number of refugees in Afghanistan and Number of refugees in El Salvador?
Provide a short and direct response. 2.50e+06. In the year 2002, what is the difference between the Number of refugees in Afghanistan and Number of refugees in Haiti?
Give a very brief answer. 2.50e+06. In the year 2002, what is the difference between the Number of refugees of El Salvador and Number of refugees of Haiti?
Ensure brevity in your answer.  -1086. In the year 2003, what is the difference between the Number of refugees in Least developed countries and Number of refugees in Afghanistan?
Your answer should be very brief. 3.51e+06. In the year 2003, what is the difference between the Number of refugees of Least developed countries and Number of refugees of El Salvador?
Your response must be concise. 5.64e+06. In the year 2003, what is the difference between the Number of refugees in Least developed countries and Number of refugees in Haiti?
Keep it short and to the point. 5.63e+06. In the year 2003, what is the difference between the Number of refugees in Afghanistan and Number of refugees in El Salvador?
Your answer should be compact. 2.13e+06. In the year 2003, what is the difference between the Number of refugees in Afghanistan and Number of refugees in Haiti?
Your response must be concise. 2.13e+06. In the year 2003, what is the difference between the Number of refugees in El Salvador and Number of refugees in Haiti?
Provide a succinct answer. -1889. In the year 2004, what is the difference between the Number of refugees in Least developed countries and Number of refugees in Afghanistan?
Offer a terse response. 3.43e+06. In the year 2004, what is the difference between the Number of refugees in Least developed countries and Number of refugees in El Salvador?
Your response must be concise. 5.84e+06. In the year 2004, what is the difference between the Number of refugees of Least developed countries and Number of refugees of Haiti?
Ensure brevity in your answer.  5.83e+06. In the year 2004, what is the difference between the Number of refugees of Afghanistan and Number of refugees of El Salvador?
Ensure brevity in your answer.  2.41e+06. In the year 2004, what is the difference between the Number of refugees of Afghanistan and Number of refugees of Haiti?
Your answer should be compact. 2.41e+06. In the year 2004, what is the difference between the Number of refugees of El Salvador and Number of refugees of Haiti?
Your answer should be very brief. -4711. What is the ratio of the Number of refugees of Least developed countries in 1997 to that in 1998?
Provide a short and direct response. 1.03. What is the ratio of the Number of refugees in El Salvador in 1997 to that in 1998?
Offer a terse response. 1.36. What is the ratio of the Number of refugees in Haiti in 1997 to that in 1998?
Your response must be concise. 1.14. What is the ratio of the Number of refugees in Least developed countries in 1997 to that in 1999?
Your response must be concise. 1. What is the ratio of the Number of refugees in Afghanistan in 1997 to that in 1999?
Ensure brevity in your answer.  1.03. What is the ratio of the Number of refugees in El Salvador in 1997 to that in 1999?
Offer a terse response. 1.38. What is the ratio of the Number of refugees of Haiti in 1997 to that in 1999?
Your answer should be very brief. 1.77. What is the ratio of the Number of refugees of Least developed countries in 1997 to that in 2000?
Your answer should be compact. 0.86. What is the ratio of the Number of refugees of Afghanistan in 1997 to that in 2000?
Make the answer very short. 0.75. What is the ratio of the Number of refugees of El Salvador in 1997 to that in 2000?
Make the answer very short. 2.21. What is the ratio of the Number of refugees in Haiti in 1997 to that in 2000?
Your answer should be very brief. 2.05. What is the ratio of the Number of refugees of Least developed countries in 1997 to that in 2001?
Give a very brief answer. 0.87. What is the ratio of the Number of refugees in Afghanistan in 1997 to that in 2001?
Offer a very short reply. 0.7. What is the ratio of the Number of refugees in El Salvador in 1997 to that in 2001?
Keep it short and to the point. 2.4. What is the ratio of the Number of refugees of Haiti in 1997 to that in 2001?
Your answer should be very brief. 2.14. What is the ratio of the Number of refugees of Least developed countries in 1997 to that in 2002?
Your answer should be compact. 1.05. What is the ratio of the Number of refugees in Afghanistan in 1997 to that in 2002?
Provide a short and direct response. 1.07. What is the ratio of the Number of refugees in El Salvador in 1997 to that in 2002?
Your response must be concise. 2.58. What is the ratio of the Number of refugees of Haiti in 1997 to that in 2002?
Keep it short and to the point. 2.01. What is the ratio of the Number of refugees in Least developed countries in 1997 to that in 2003?
Ensure brevity in your answer.  1.17. What is the ratio of the Number of refugees in Afghanistan in 1997 to that in 2003?
Keep it short and to the point. 1.25. What is the ratio of the Number of refugees of El Salvador in 1997 to that in 2003?
Provide a succinct answer. 3.03. What is the ratio of the Number of refugees in Haiti in 1997 to that in 2003?
Provide a short and direct response. 2.05. What is the ratio of the Number of refugees in Least developed countries in 1997 to that in 2004?
Offer a very short reply. 1.13. What is the ratio of the Number of refugees in Afghanistan in 1997 to that in 2004?
Make the answer very short. 1.11. What is the ratio of the Number of refugees of El Salvador in 1997 to that in 2004?
Make the answer very short. 3.81. What is the ratio of the Number of refugees in Haiti in 1997 to that in 2004?
Ensure brevity in your answer.  1.68. What is the ratio of the Number of refugees in Least developed countries in 1998 to that in 1999?
Offer a terse response. 0.96. What is the ratio of the Number of refugees in Afghanistan in 1998 to that in 1999?
Your response must be concise. 1.03. What is the ratio of the Number of refugees of El Salvador in 1998 to that in 1999?
Make the answer very short. 1.01. What is the ratio of the Number of refugees in Haiti in 1998 to that in 1999?
Ensure brevity in your answer.  1.54. What is the ratio of the Number of refugees in Least developed countries in 1998 to that in 2000?
Provide a succinct answer. 0.83. What is the ratio of the Number of refugees of Afghanistan in 1998 to that in 2000?
Provide a succinct answer. 0.74. What is the ratio of the Number of refugees in El Salvador in 1998 to that in 2000?
Make the answer very short. 1.62. What is the ratio of the Number of refugees of Haiti in 1998 to that in 2000?
Your answer should be compact. 1.79. What is the ratio of the Number of refugees of Least developed countries in 1998 to that in 2001?
Your answer should be compact. 0.84. What is the ratio of the Number of refugees in Afghanistan in 1998 to that in 2001?
Ensure brevity in your answer.  0.7. What is the ratio of the Number of refugees of El Salvador in 1998 to that in 2001?
Give a very brief answer. 1.76. What is the ratio of the Number of refugees in Haiti in 1998 to that in 2001?
Your response must be concise. 1.87. What is the ratio of the Number of refugees in Least developed countries in 1998 to that in 2002?
Provide a succinct answer. 1.02. What is the ratio of the Number of refugees in Afghanistan in 1998 to that in 2002?
Offer a terse response. 1.06. What is the ratio of the Number of refugees of El Salvador in 1998 to that in 2002?
Ensure brevity in your answer.  1.9. What is the ratio of the Number of refugees of Haiti in 1998 to that in 2002?
Make the answer very short. 1.75. What is the ratio of the Number of refugees in Least developed countries in 1998 to that in 2003?
Provide a short and direct response. 1.14. What is the ratio of the Number of refugees in Afghanistan in 1998 to that in 2003?
Offer a very short reply. 1.25. What is the ratio of the Number of refugees of El Salvador in 1998 to that in 2003?
Your answer should be very brief. 2.23. What is the ratio of the Number of refugees in Haiti in 1998 to that in 2003?
Make the answer very short. 1.79. What is the ratio of the Number of refugees in Least developed countries in 1998 to that in 2004?
Ensure brevity in your answer.  1.1. What is the ratio of the Number of refugees of Afghanistan in 1998 to that in 2004?
Your answer should be very brief. 1.1. What is the ratio of the Number of refugees in El Salvador in 1998 to that in 2004?
Provide a succinct answer. 2.8. What is the ratio of the Number of refugees of Haiti in 1998 to that in 2004?
Your answer should be very brief. 1.47. What is the ratio of the Number of refugees of Least developed countries in 1999 to that in 2000?
Make the answer very short. 0.86. What is the ratio of the Number of refugees in Afghanistan in 1999 to that in 2000?
Your response must be concise. 0.73. What is the ratio of the Number of refugees in El Salvador in 1999 to that in 2000?
Your response must be concise. 1.6. What is the ratio of the Number of refugees of Haiti in 1999 to that in 2000?
Give a very brief answer. 1.16. What is the ratio of the Number of refugees of Least developed countries in 1999 to that in 2001?
Your answer should be compact. 0.87. What is the ratio of the Number of refugees of Afghanistan in 1999 to that in 2001?
Offer a terse response. 0.68. What is the ratio of the Number of refugees of El Salvador in 1999 to that in 2001?
Ensure brevity in your answer.  1.74. What is the ratio of the Number of refugees of Haiti in 1999 to that in 2001?
Offer a terse response. 1.21. What is the ratio of the Number of refugees of Least developed countries in 1999 to that in 2002?
Offer a terse response. 1.06. What is the ratio of the Number of refugees in Afghanistan in 1999 to that in 2002?
Your response must be concise. 1.04. What is the ratio of the Number of refugees in El Salvador in 1999 to that in 2002?
Offer a very short reply. 1.87. What is the ratio of the Number of refugees in Haiti in 1999 to that in 2002?
Offer a terse response. 1.14. What is the ratio of the Number of refugees in Least developed countries in 1999 to that in 2003?
Your response must be concise. 1.18. What is the ratio of the Number of refugees of Afghanistan in 1999 to that in 2003?
Offer a very short reply. 1.22. What is the ratio of the Number of refugees in El Salvador in 1999 to that in 2003?
Ensure brevity in your answer.  2.19. What is the ratio of the Number of refugees of Haiti in 1999 to that in 2003?
Offer a very short reply. 1.16. What is the ratio of the Number of refugees in Least developed countries in 1999 to that in 2004?
Provide a short and direct response. 1.14. What is the ratio of the Number of refugees in Afghanistan in 1999 to that in 2004?
Keep it short and to the point. 1.08. What is the ratio of the Number of refugees in El Salvador in 1999 to that in 2004?
Give a very brief answer. 2.76. What is the ratio of the Number of refugees of Haiti in 1999 to that in 2004?
Keep it short and to the point. 0.95. What is the ratio of the Number of refugees of Least developed countries in 2000 to that in 2001?
Offer a very short reply. 1.02. What is the ratio of the Number of refugees in Afghanistan in 2000 to that in 2001?
Provide a succinct answer. 0.94. What is the ratio of the Number of refugees of El Salvador in 2000 to that in 2001?
Give a very brief answer. 1.08. What is the ratio of the Number of refugees of Haiti in 2000 to that in 2001?
Your answer should be very brief. 1.04. What is the ratio of the Number of refugees of Least developed countries in 2000 to that in 2002?
Offer a terse response. 1.23. What is the ratio of the Number of refugees of Afghanistan in 2000 to that in 2002?
Provide a succinct answer. 1.43. What is the ratio of the Number of refugees in El Salvador in 2000 to that in 2002?
Your answer should be very brief. 1.17. What is the ratio of the Number of refugees of Haiti in 2000 to that in 2002?
Offer a very short reply. 0.98. What is the ratio of the Number of refugees in Least developed countries in 2000 to that in 2003?
Provide a succinct answer. 1.37. What is the ratio of the Number of refugees in Afghanistan in 2000 to that in 2003?
Make the answer very short. 1.68. What is the ratio of the Number of refugees of El Salvador in 2000 to that in 2003?
Offer a very short reply. 1.37. What is the ratio of the Number of refugees in Least developed countries in 2000 to that in 2004?
Your answer should be compact. 1.32. What is the ratio of the Number of refugees in Afghanistan in 2000 to that in 2004?
Your answer should be very brief. 1.49. What is the ratio of the Number of refugees in El Salvador in 2000 to that in 2004?
Offer a terse response. 1.72. What is the ratio of the Number of refugees in Haiti in 2000 to that in 2004?
Provide a succinct answer. 0.82. What is the ratio of the Number of refugees in Least developed countries in 2001 to that in 2002?
Your response must be concise. 1.21. What is the ratio of the Number of refugees of Afghanistan in 2001 to that in 2002?
Offer a terse response. 1.52. What is the ratio of the Number of refugees in El Salvador in 2001 to that in 2002?
Give a very brief answer. 1.08. What is the ratio of the Number of refugees of Haiti in 2001 to that in 2002?
Give a very brief answer. 0.94. What is the ratio of the Number of refugees in Least developed countries in 2001 to that in 2003?
Offer a very short reply. 1.35. What is the ratio of the Number of refugees of Afghanistan in 2001 to that in 2003?
Offer a terse response. 1.78. What is the ratio of the Number of refugees of El Salvador in 2001 to that in 2003?
Provide a succinct answer. 1.26. What is the ratio of the Number of refugees in Haiti in 2001 to that in 2003?
Give a very brief answer. 0.96. What is the ratio of the Number of refugees in Least developed countries in 2001 to that in 2004?
Provide a succinct answer. 1.3. What is the ratio of the Number of refugees of Afghanistan in 2001 to that in 2004?
Offer a very short reply. 1.58. What is the ratio of the Number of refugees of El Salvador in 2001 to that in 2004?
Your answer should be very brief. 1.59. What is the ratio of the Number of refugees in Haiti in 2001 to that in 2004?
Your response must be concise. 0.79. What is the ratio of the Number of refugees in Least developed countries in 2002 to that in 2003?
Ensure brevity in your answer.  1.11. What is the ratio of the Number of refugees of Afghanistan in 2002 to that in 2003?
Your response must be concise. 1.18. What is the ratio of the Number of refugees of El Salvador in 2002 to that in 2003?
Keep it short and to the point. 1.17. What is the ratio of the Number of refugees in Haiti in 2002 to that in 2003?
Make the answer very short. 1.02. What is the ratio of the Number of refugees of Least developed countries in 2002 to that in 2004?
Make the answer very short. 1.07. What is the ratio of the Number of refugees of Afghanistan in 2002 to that in 2004?
Provide a succinct answer. 1.04. What is the ratio of the Number of refugees of El Salvador in 2002 to that in 2004?
Keep it short and to the point. 1.47. What is the ratio of the Number of refugees in Haiti in 2002 to that in 2004?
Your answer should be compact. 0.84. What is the ratio of the Number of refugees in Least developed countries in 2003 to that in 2004?
Provide a short and direct response. 0.97. What is the ratio of the Number of refugees of Afghanistan in 2003 to that in 2004?
Offer a terse response. 0.88. What is the ratio of the Number of refugees in El Salvador in 2003 to that in 2004?
Keep it short and to the point. 1.26. What is the ratio of the Number of refugees of Haiti in 2003 to that in 2004?
Make the answer very short. 0.82. What is the difference between the highest and the second highest Number of refugees of Least developed countries?
Keep it short and to the point. 1.26e+05. What is the difference between the highest and the second highest Number of refugees of Afghanistan?
Ensure brevity in your answer.  2.22e+05. What is the difference between the highest and the second highest Number of refugees in El Salvador?
Your answer should be very brief. 4535. What is the difference between the highest and the second highest Number of refugees of Haiti?
Keep it short and to the point. 1943. What is the difference between the highest and the lowest Number of refugees of Least developed countries?
Your answer should be compact. 2.10e+06. What is the difference between the highest and the lowest Number of refugees of Afghanistan?
Your response must be concise. 1.67e+06. What is the difference between the highest and the lowest Number of refugees in El Salvador?
Your response must be concise. 1.26e+04. What is the difference between the highest and the lowest Number of refugees of Haiti?
Offer a very short reply. 8233. 